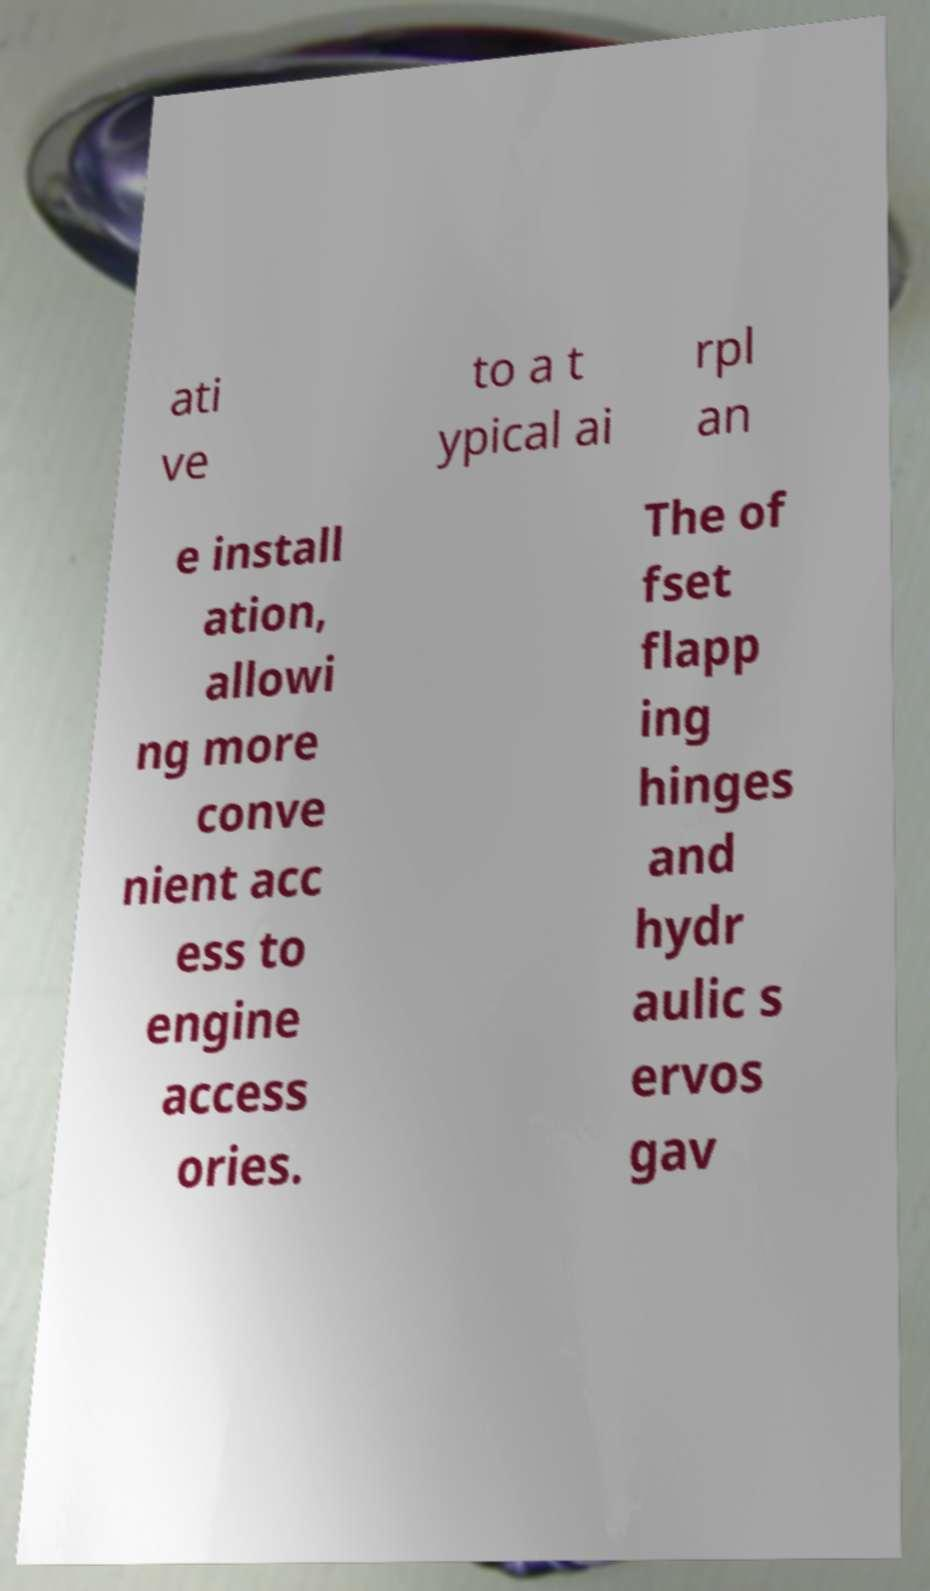Can you accurately transcribe the text from the provided image for me? ati ve to a t ypical ai rpl an e install ation, allowi ng more conve nient acc ess to engine access ories. The of fset flapp ing hinges and hydr aulic s ervos gav 